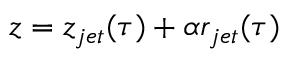Convert formula to latex. <formula><loc_0><loc_0><loc_500><loc_500>z = z _ { j e t } ( \tau ) + \alpha r _ { j e t } ( \tau )</formula> 